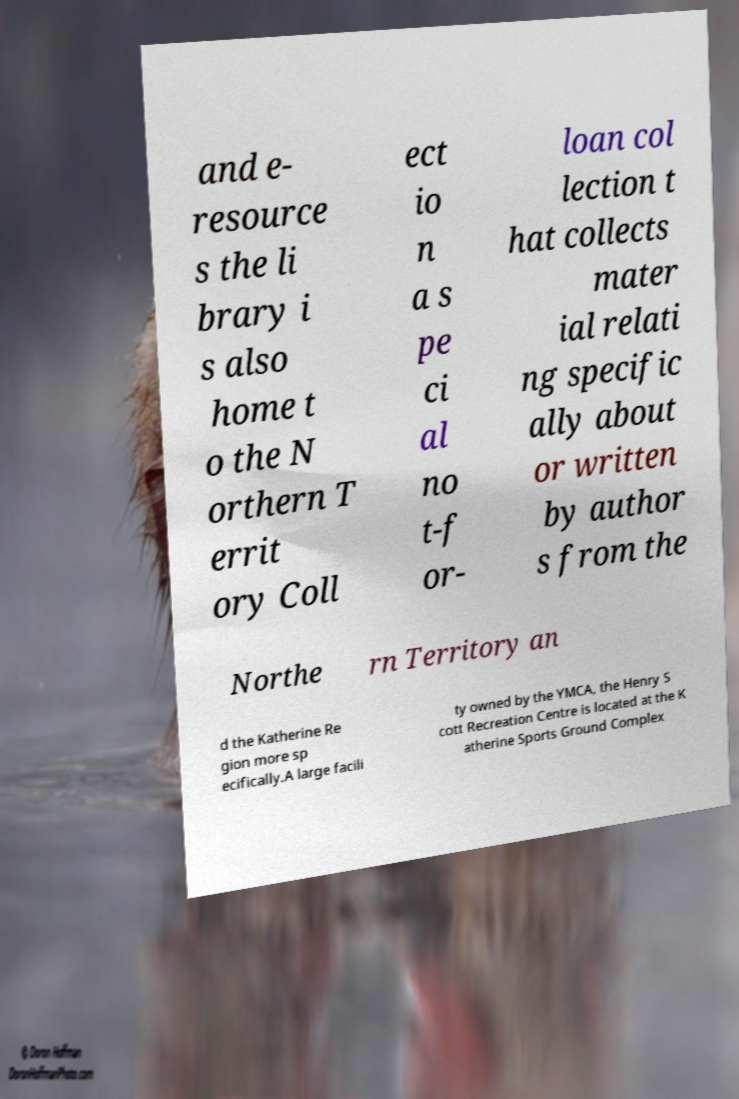What messages or text are displayed in this image? I need them in a readable, typed format. and e- resource s the li brary i s also home t o the N orthern T errit ory Coll ect io n a s pe ci al no t-f or- loan col lection t hat collects mater ial relati ng specific ally about or written by author s from the Northe rn Territory an d the Katherine Re gion more sp ecifically.A large facili ty owned by the YMCA, the Henry S cott Recreation Centre is located at the K atherine Sports Ground Complex 